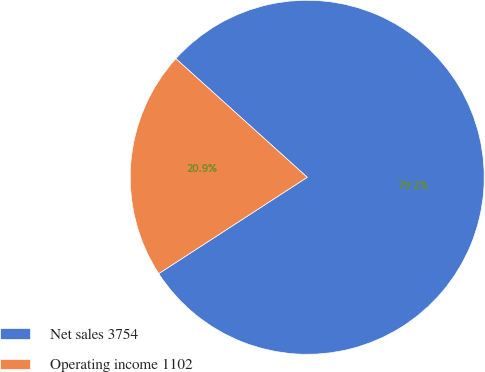Convert chart to OTSL. <chart><loc_0><loc_0><loc_500><loc_500><pie_chart><fcel>Net sales 3754<fcel>Operating income 1102<nl><fcel>79.15%<fcel>20.85%<nl></chart> 